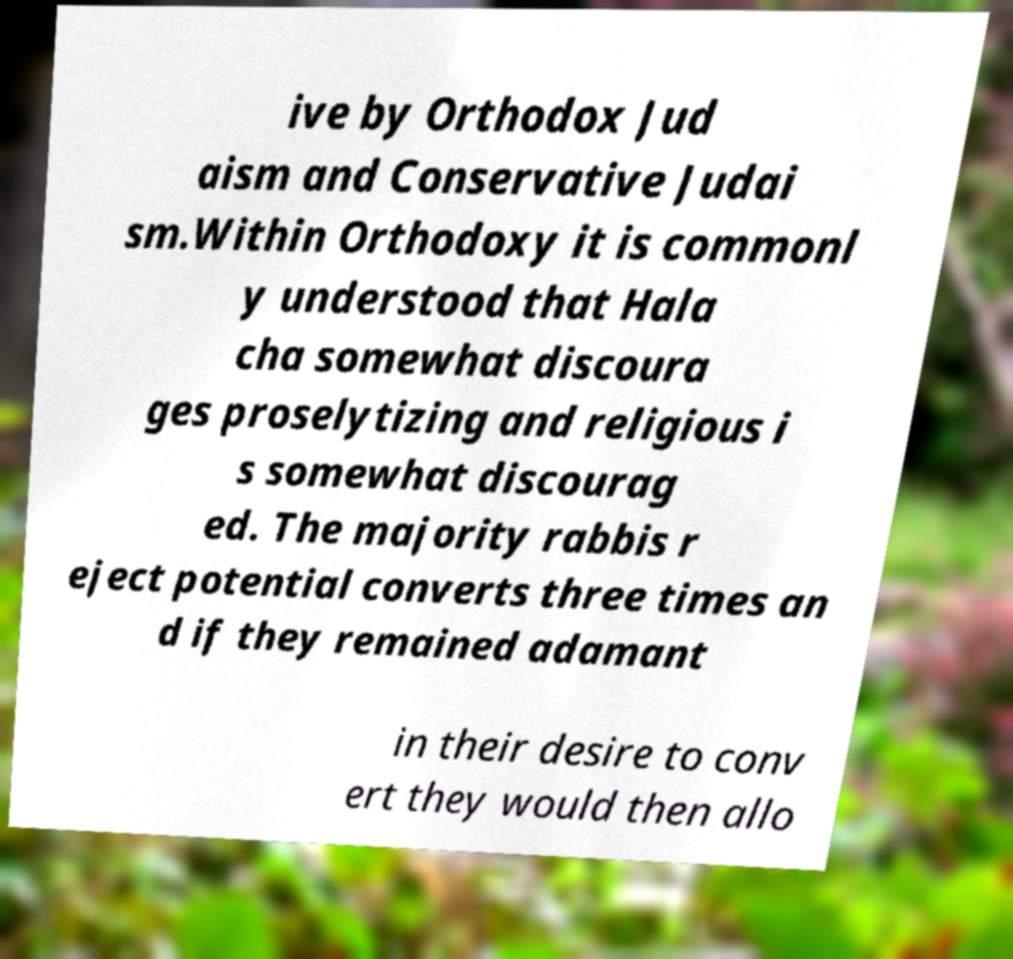What messages or text are displayed in this image? I need them in a readable, typed format. ive by Orthodox Jud aism and Conservative Judai sm.Within Orthodoxy it is commonl y understood that Hala cha somewhat discoura ges proselytizing and religious i s somewhat discourag ed. The majority rabbis r eject potential converts three times an d if they remained adamant in their desire to conv ert they would then allo 